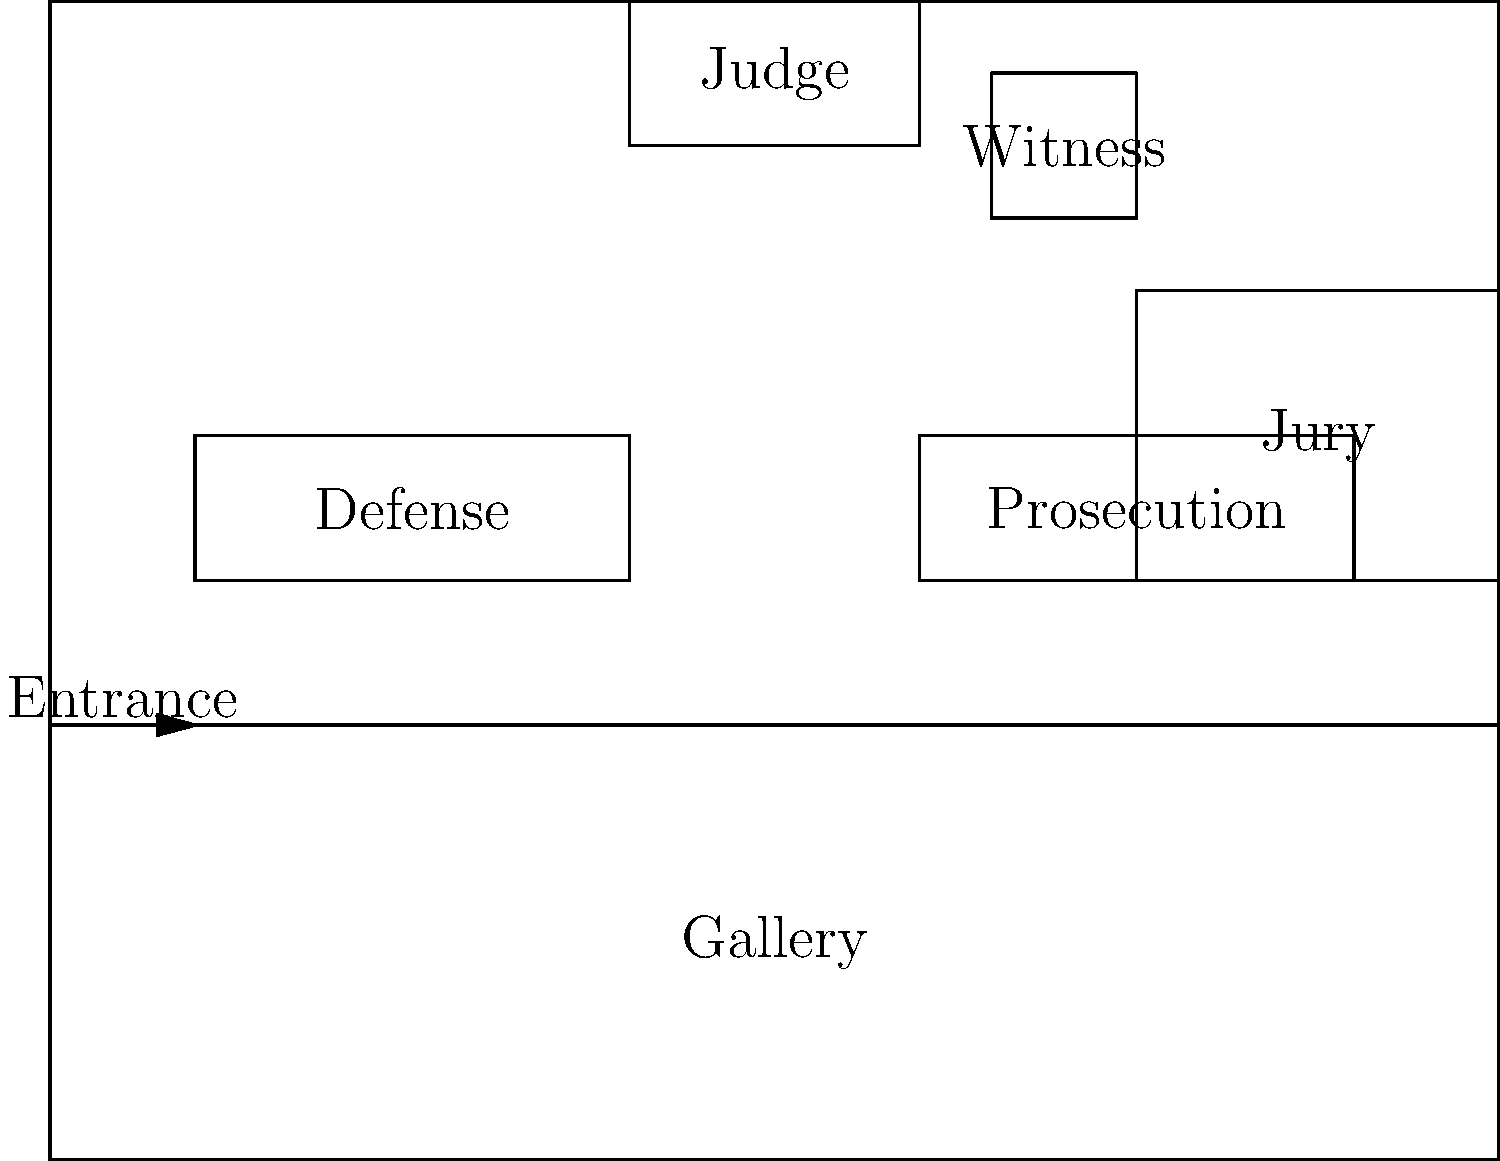In the typical courtroom layout shown, which area is closest to the judge's bench? To determine which area is closest to the judge's bench, let's analyze the layout step-by-step:

1. The judge's bench is located at the top center of the courtroom.
2. Directly to the right of the judge's bench is the witness stand.
3. The jury box is positioned to the right side of the courtroom, but not as close to the judge as the witness stand.
4. The defense and prosecution tables are in the middle of the courtroom, equidistant from the judge's bench.
5. The gallery is at the back of the courtroom, farthest from the judge's bench.

Based on this analysis, the witness stand is the area closest to the judge's bench in the typical courtroom layout presented.
Answer: Witness stand 